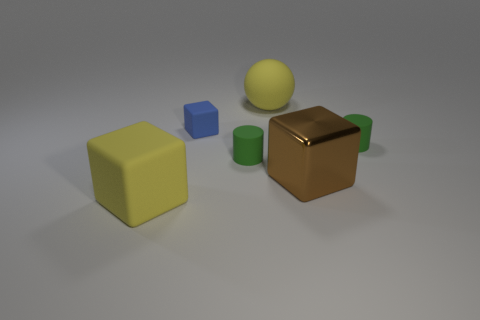There is a yellow thing that is behind the large yellow matte object on the left side of the small blue object; are there any tiny blue matte objects in front of it?
Your answer should be very brief. Yes. Is there any other thing that is made of the same material as the brown object?
Offer a very short reply. No. The big thing that is made of the same material as the yellow block is what shape?
Make the answer very short. Sphere. Are there fewer cylinders that are left of the large metal block than green cylinders behind the big yellow cube?
Your answer should be very brief. Yes. How many tiny objects are either metal objects or blue cylinders?
Ensure brevity in your answer.  0. There is a large rubber thing that is in front of the yellow sphere; is its shape the same as the big thing that is on the right side of the yellow ball?
Keep it short and to the point. Yes. There is a matte cylinder to the left of the big block that is to the right of the yellow matte thing that is in front of the tiny cube; what is its size?
Provide a short and direct response. Small. What is the size of the rubber object behind the small cube?
Your answer should be very brief. Large. There is a large brown block on the right side of the small blue cube; what is its material?
Ensure brevity in your answer.  Metal. What number of purple objects are big rubber objects or large rubber blocks?
Offer a very short reply. 0. 